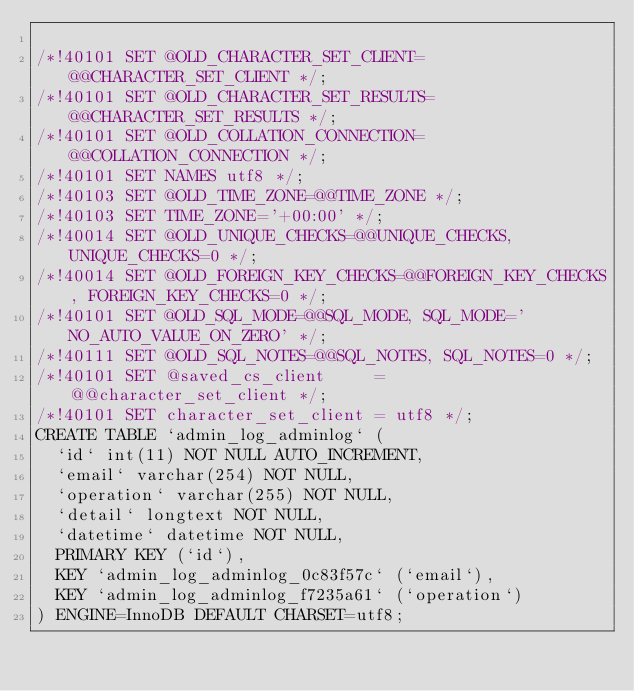<code> <loc_0><loc_0><loc_500><loc_500><_SQL_>
/*!40101 SET @OLD_CHARACTER_SET_CLIENT=@@CHARACTER_SET_CLIENT */;
/*!40101 SET @OLD_CHARACTER_SET_RESULTS=@@CHARACTER_SET_RESULTS */;
/*!40101 SET @OLD_COLLATION_CONNECTION=@@COLLATION_CONNECTION */;
/*!40101 SET NAMES utf8 */;
/*!40103 SET @OLD_TIME_ZONE=@@TIME_ZONE */;
/*!40103 SET TIME_ZONE='+00:00' */;
/*!40014 SET @OLD_UNIQUE_CHECKS=@@UNIQUE_CHECKS, UNIQUE_CHECKS=0 */;
/*!40014 SET @OLD_FOREIGN_KEY_CHECKS=@@FOREIGN_KEY_CHECKS, FOREIGN_KEY_CHECKS=0 */;
/*!40101 SET @OLD_SQL_MODE=@@SQL_MODE, SQL_MODE='NO_AUTO_VALUE_ON_ZERO' */;
/*!40111 SET @OLD_SQL_NOTES=@@SQL_NOTES, SQL_NOTES=0 */;
/*!40101 SET @saved_cs_client     = @@character_set_client */;
/*!40101 SET character_set_client = utf8 */;
CREATE TABLE `admin_log_adminlog` (
  `id` int(11) NOT NULL AUTO_INCREMENT,
  `email` varchar(254) NOT NULL,
  `operation` varchar(255) NOT NULL,
  `detail` longtext NOT NULL,
  `datetime` datetime NOT NULL,
  PRIMARY KEY (`id`),
  KEY `admin_log_adminlog_0c83f57c` (`email`),
  KEY `admin_log_adminlog_f7235a61` (`operation`)
) ENGINE=InnoDB DEFAULT CHARSET=utf8;</code> 